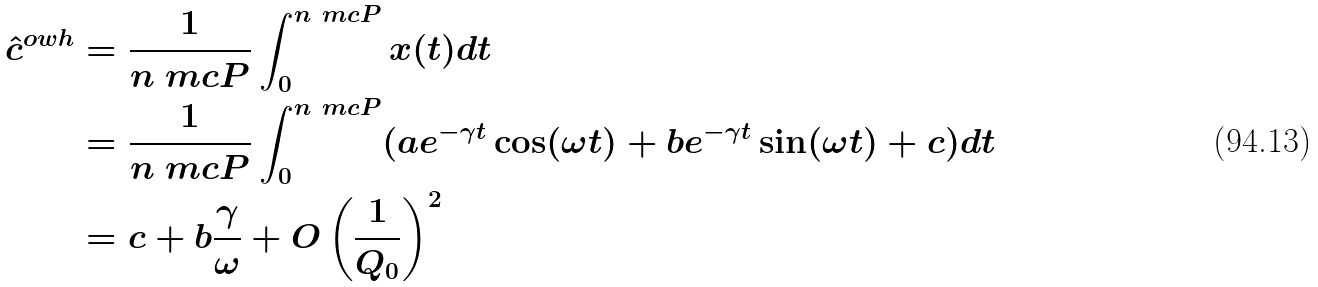Convert formula to latex. <formula><loc_0><loc_0><loc_500><loc_500>\hat { c } ^ { o w h } & = \frac { 1 } { n \ m c { P } } \int _ { 0 } ^ { n \ m c { P } } x ( t ) d t \\ & = \frac { 1 } { n \ m c { P } } \int _ { 0 } ^ { n \ m c { P } } ( a e ^ { - \gamma t } \cos ( \omega t ) + b e ^ { - \gamma t } \sin ( \omega t ) + c ) d t \\ & = c + b \frac { \gamma } { \omega } + O \left ( \frac { 1 } { Q _ { 0 } } \right ) ^ { 2 }</formula> 